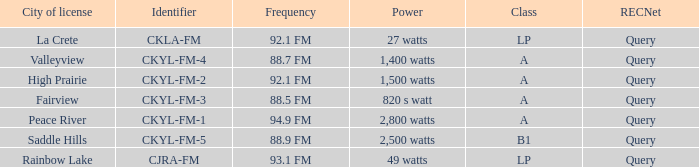Can you give me this table as a dict? {'header': ['City of license', 'Identifier', 'Frequency', 'Power', 'Class', 'RECNet'], 'rows': [['La Crete', 'CKLA-FM', '92.1 FM', '27 watts', 'LP', 'Query'], ['Valleyview', 'CKYL-FM-4', '88.7 FM', '1,400 watts', 'A', 'Query'], ['High Prairie', 'CKYL-FM-2', '92.1 FM', '1,500 watts', 'A', 'Query'], ['Fairview', 'CKYL-FM-3', '88.5 FM', '820 s watt', 'A', 'Query'], ['Peace River', 'CKYL-FM-1', '94.9 FM', '2,800 watts', 'A', 'Query'], ['Saddle Hills', 'CKYL-FM-5', '88.9 FM', '2,500 watts', 'B1', 'Query'], ['Rainbow Lake', 'CJRA-FM', '93.1 FM', '49 watts', 'LP', 'Query']]} What is the power with 88.5 fm frequency 820 s watt. 